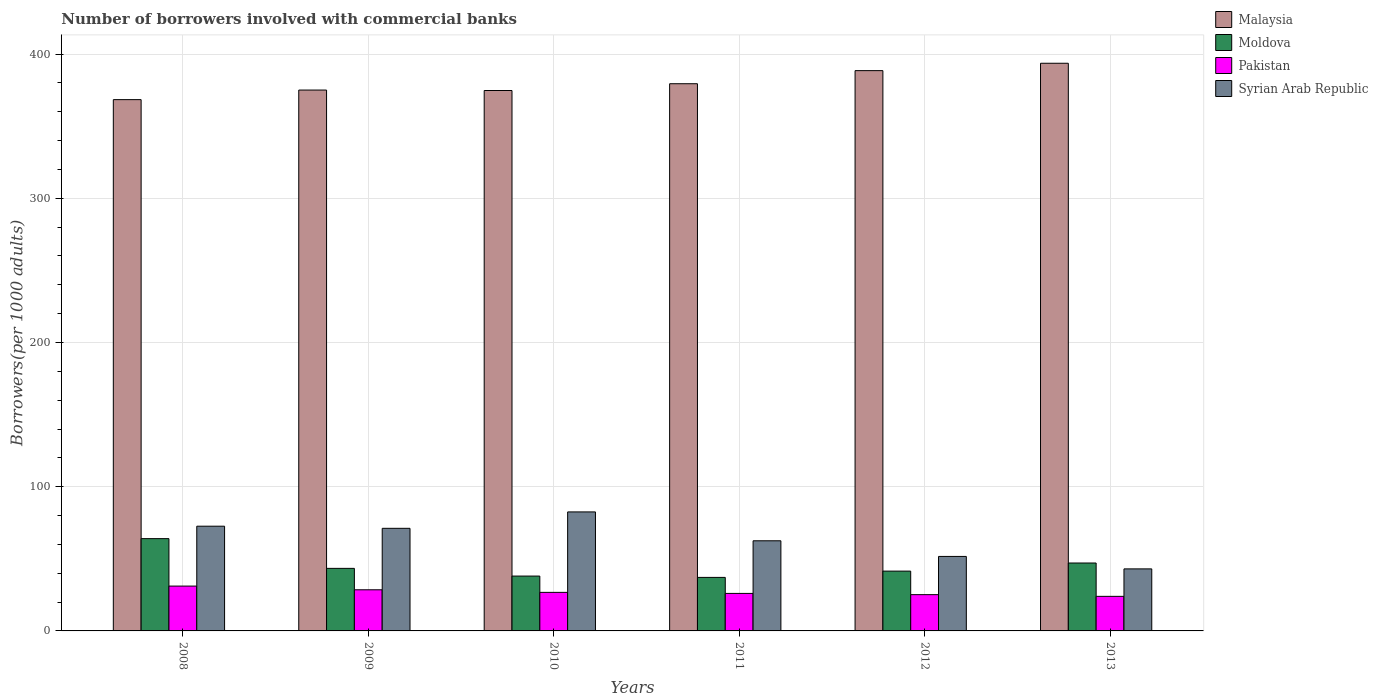How many different coloured bars are there?
Ensure brevity in your answer.  4. How many groups of bars are there?
Offer a terse response. 6. Are the number of bars per tick equal to the number of legend labels?
Provide a short and direct response. Yes. What is the number of borrowers involved with commercial banks in Syrian Arab Republic in 2010?
Ensure brevity in your answer.  82.52. Across all years, what is the maximum number of borrowers involved with commercial banks in Malaysia?
Give a very brief answer. 393.61. Across all years, what is the minimum number of borrowers involved with commercial banks in Moldova?
Provide a short and direct response. 37.11. In which year was the number of borrowers involved with commercial banks in Malaysia minimum?
Provide a succinct answer. 2008. What is the total number of borrowers involved with commercial banks in Malaysia in the graph?
Your answer should be compact. 2279.66. What is the difference between the number of borrowers involved with commercial banks in Pakistan in 2009 and that in 2012?
Your response must be concise. 3.37. What is the difference between the number of borrowers involved with commercial banks in Syrian Arab Republic in 2011 and the number of borrowers involved with commercial banks in Pakistan in 2009?
Keep it short and to the point. 33.98. What is the average number of borrowers involved with commercial banks in Syrian Arab Republic per year?
Ensure brevity in your answer.  63.91. In the year 2013, what is the difference between the number of borrowers involved with commercial banks in Pakistan and number of borrowers involved with commercial banks in Malaysia?
Offer a very short reply. -369.64. In how many years, is the number of borrowers involved with commercial banks in Malaysia greater than 140?
Give a very brief answer. 6. What is the ratio of the number of borrowers involved with commercial banks in Moldova in 2010 to that in 2011?
Offer a very short reply. 1.02. Is the number of borrowers involved with commercial banks in Syrian Arab Republic in 2009 less than that in 2013?
Offer a terse response. No. Is the difference between the number of borrowers involved with commercial banks in Pakistan in 2010 and 2011 greater than the difference between the number of borrowers involved with commercial banks in Malaysia in 2010 and 2011?
Your answer should be compact. Yes. What is the difference between the highest and the second highest number of borrowers involved with commercial banks in Malaysia?
Ensure brevity in your answer.  5.12. What is the difference between the highest and the lowest number of borrowers involved with commercial banks in Moldova?
Offer a terse response. 26.87. Is the sum of the number of borrowers involved with commercial banks in Malaysia in 2010 and 2013 greater than the maximum number of borrowers involved with commercial banks in Moldova across all years?
Your answer should be very brief. Yes. Is it the case that in every year, the sum of the number of borrowers involved with commercial banks in Pakistan and number of borrowers involved with commercial banks in Malaysia is greater than the sum of number of borrowers involved with commercial banks in Moldova and number of borrowers involved with commercial banks in Syrian Arab Republic?
Make the answer very short. No. What does the 4th bar from the left in 2012 represents?
Your answer should be very brief. Syrian Arab Republic. What does the 1st bar from the right in 2008 represents?
Ensure brevity in your answer.  Syrian Arab Republic. How many bars are there?
Your response must be concise. 24. Are the values on the major ticks of Y-axis written in scientific E-notation?
Ensure brevity in your answer.  No. Where does the legend appear in the graph?
Your answer should be very brief. Top right. How many legend labels are there?
Your answer should be compact. 4. What is the title of the graph?
Keep it short and to the point. Number of borrowers involved with commercial banks. Does "High income" appear as one of the legend labels in the graph?
Your answer should be very brief. No. What is the label or title of the X-axis?
Your answer should be compact. Years. What is the label or title of the Y-axis?
Your answer should be compact. Borrowers(per 1000 adults). What is the Borrowers(per 1000 adults) in Malaysia in 2008?
Your response must be concise. 368.39. What is the Borrowers(per 1000 adults) of Moldova in 2008?
Your answer should be compact. 63.99. What is the Borrowers(per 1000 adults) in Pakistan in 2008?
Keep it short and to the point. 31.09. What is the Borrowers(per 1000 adults) of Syrian Arab Republic in 2008?
Your answer should be compact. 72.62. What is the Borrowers(per 1000 adults) of Malaysia in 2009?
Your answer should be compact. 375.03. What is the Borrowers(per 1000 adults) of Moldova in 2009?
Provide a short and direct response. 43.38. What is the Borrowers(per 1000 adults) of Pakistan in 2009?
Offer a terse response. 28.52. What is the Borrowers(per 1000 adults) of Syrian Arab Republic in 2009?
Make the answer very short. 71.15. What is the Borrowers(per 1000 adults) of Malaysia in 2010?
Keep it short and to the point. 374.71. What is the Borrowers(per 1000 adults) of Moldova in 2010?
Your answer should be very brief. 38.03. What is the Borrowers(per 1000 adults) of Pakistan in 2010?
Keep it short and to the point. 26.73. What is the Borrowers(per 1000 adults) in Syrian Arab Republic in 2010?
Provide a short and direct response. 82.52. What is the Borrowers(per 1000 adults) of Malaysia in 2011?
Provide a succinct answer. 379.42. What is the Borrowers(per 1000 adults) in Moldova in 2011?
Your response must be concise. 37.11. What is the Borrowers(per 1000 adults) of Pakistan in 2011?
Your answer should be compact. 26.01. What is the Borrowers(per 1000 adults) of Syrian Arab Republic in 2011?
Provide a succinct answer. 62.5. What is the Borrowers(per 1000 adults) of Malaysia in 2012?
Give a very brief answer. 388.49. What is the Borrowers(per 1000 adults) in Moldova in 2012?
Your answer should be compact. 41.47. What is the Borrowers(per 1000 adults) of Pakistan in 2012?
Provide a succinct answer. 25.15. What is the Borrowers(per 1000 adults) in Syrian Arab Republic in 2012?
Your response must be concise. 51.65. What is the Borrowers(per 1000 adults) in Malaysia in 2013?
Your answer should be compact. 393.61. What is the Borrowers(per 1000 adults) in Moldova in 2013?
Make the answer very short. 47.09. What is the Borrowers(per 1000 adults) in Pakistan in 2013?
Keep it short and to the point. 23.97. What is the Borrowers(per 1000 adults) in Syrian Arab Republic in 2013?
Give a very brief answer. 43.01. Across all years, what is the maximum Borrowers(per 1000 adults) of Malaysia?
Your response must be concise. 393.61. Across all years, what is the maximum Borrowers(per 1000 adults) of Moldova?
Keep it short and to the point. 63.99. Across all years, what is the maximum Borrowers(per 1000 adults) of Pakistan?
Ensure brevity in your answer.  31.09. Across all years, what is the maximum Borrowers(per 1000 adults) in Syrian Arab Republic?
Offer a terse response. 82.52. Across all years, what is the minimum Borrowers(per 1000 adults) in Malaysia?
Offer a very short reply. 368.39. Across all years, what is the minimum Borrowers(per 1000 adults) in Moldova?
Make the answer very short. 37.11. Across all years, what is the minimum Borrowers(per 1000 adults) of Pakistan?
Make the answer very short. 23.97. Across all years, what is the minimum Borrowers(per 1000 adults) of Syrian Arab Republic?
Offer a very short reply. 43.01. What is the total Borrowers(per 1000 adults) in Malaysia in the graph?
Your answer should be very brief. 2279.66. What is the total Borrowers(per 1000 adults) of Moldova in the graph?
Ensure brevity in your answer.  271.07. What is the total Borrowers(per 1000 adults) in Pakistan in the graph?
Keep it short and to the point. 161.46. What is the total Borrowers(per 1000 adults) of Syrian Arab Republic in the graph?
Your response must be concise. 383.44. What is the difference between the Borrowers(per 1000 adults) in Malaysia in 2008 and that in 2009?
Provide a succinct answer. -6.64. What is the difference between the Borrowers(per 1000 adults) of Moldova in 2008 and that in 2009?
Provide a succinct answer. 20.61. What is the difference between the Borrowers(per 1000 adults) of Pakistan in 2008 and that in 2009?
Your response must be concise. 2.57. What is the difference between the Borrowers(per 1000 adults) in Syrian Arab Republic in 2008 and that in 2009?
Make the answer very short. 1.47. What is the difference between the Borrowers(per 1000 adults) of Malaysia in 2008 and that in 2010?
Provide a succinct answer. -6.32. What is the difference between the Borrowers(per 1000 adults) in Moldova in 2008 and that in 2010?
Keep it short and to the point. 25.95. What is the difference between the Borrowers(per 1000 adults) of Pakistan in 2008 and that in 2010?
Provide a short and direct response. 4.36. What is the difference between the Borrowers(per 1000 adults) in Syrian Arab Republic in 2008 and that in 2010?
Make the answer very short. -9.9. What is the difference between the Borrowers(per 1000 adults) of Malaysia in 2008 and that in 2011?
Your answer should be compact. -11.03. What is the difference between the Borrowers(per 1000 adults) of Moldova in 2008 and that in 2011?
Give a very brief answer. 26.87. What is the difference between the Borrowers(per 1000 adults) of Pakistan in 2008 and that in 2011?
Offer a terse response. 5.08. What is the difference between the Borrowers(per 1000 adults) of Syrian Arab Republic in 2008 and that in 2011?
Offer a terse response. 10.12. What is the difference between the Borrowers(per 1000 adults) of Malaysia in 2008 and that in 2012?
Make the answer very short. -20.1. What is the difference between the Borrowers(per 1000 adults) in Moldova in 2008 and that in 2012?
Ensure brevity in your answer.  22.52. What is the difference between the Borrowers(per 1000 adults) in Pakistan in 2008 and that in 2012?
Keep it short and to the point. 5.94. What is the difference between the Borrowers(per 1000 adults) of Syrian Arab Republic in 2008 and that in 2012?
Make the answer very short. 20.97. What is the difference between the Borrowers(per 1000 adults) in Malaysia in 2008 and that in 2013?
Offer a terse response. -25.22. What is the difference between the Borrowers(per 1000 adults) of Moldova in 2008 and that in 2013?
Offer a very short reply. 16.9. What is the difference between the Borrowers(per 1000 adults) of Pakistan in 2008 and that in 2013?
Your response must be concise. 7.13. What is the difference between the Borrowers(per 1000 adults) of Syrian Arab Republic in 2008 and that in 2013?
Offer a very short reply. 29.61. What is the difference between the Borrowers(per 1000 adults) of Malaysia in 2009 and that in 2010?
Ensure brevity in your answer.  0.32. What is the difference between the Borrowers(per 1000 adults) of Moldova in 2009 and that in 2010?
Your answer should be very brief. 5.34. What is the difference between the Borrowers(per 1000 adults) of Pakistan in 2009 and that in 2010?
Offer a very short reply. 1.79. What is the difference between the Borrowers(per 1000 adults) of Syrian Arab Republic in 2009 and that in 2010?
Ensure brevity in your answer.  -11.37. What is the difference between the Borrowers(per 1000 adults) of Malaysia in 2009 and that in 2011?
Offer a terse response. -4.39. What is the difference between the Borrowers(per 1000 adults) of Moldova in 2009 and that in 2011?
Your response must be concise. 6.26. What is the difference between the Borrowers(per 1000 adults) of Pakistan in 2009 and that in 2011?
Provide a short and direct response. 2.51. What is the difference between the Borrowers(per 1000 adults) of Syrian Arab Republic in 2009 and that in 2011?
Make the answer very short. 8.65. What is the difference between the Borrowers(per 1000 adults) of Malaysia in 2009 and that in 2012?
Give a very brief answer. -13.46. What is the difference between the Borrowers(per 1000 adults) of Moldova in 2009 and that in 2012?
Ensure brevity in your answer.  1.91. What is the difference between the Borrowers(per 1000 adults) in Pakistan in 2009 and that in 2012?
Your response must be concise. 3.37. What is the difference between the Borrowers(per 1000 adults) in Syrian Arab Republic in 2009 and that in 2012?
Your response must be concise. 19.5. What is the difference between the Borrowers(per 1000 adults) in Malaysia in 2009 and that in 2013?
Offer a terse response. -18.58. What is the difference between the Borrowers(per 1000 adults) of Moldova in 2009 and that in 2013?
Offer a terse response. -3.71. What is the difference between the Borrowers(per 1000 adults) of Pakistan in 2009 and that in 2013?
Provide a succinct answer. 4.55. What is the difference between the Borrowers(per 1000 adults) in Syrian Arab Republic in 2009 and that in 2013?
Ensure brevity in your answer.  28.13. What is the difference between the Borrowers(per 1000 adults) in Malaysia in 2010 and that in 2011?
Keep it short and to the point. -4.71. What is the difference between the Borrowers(per 1000 adults) in Moldova in 2010 and that in 2011?
Your answer should be compact. 0.92. What is the difference between the Borrowers(per 1000 adults) in Pakistan in 2010 and that in 2011?
Provide a short and direct response. 0.72. What is the difference between the Borrowers(per 1000 adults) of Syrian Arab Republic in 2010 and that in 2011?
Ensure brevity in your answer.  20.02. What is the difference between the Borrowers(per 1000 adults) of Malaysia in 2010 and that in 2012?
Offer a terse response. -13.78. What is the difference between the Borrowers(per 1000 adults) in Moldova in 2010 and that in 2012?
Your response must be concise. -3.43. What is the difference between the Borrowers(per 1000 adults) in Pakistan in 2010 and that in 2012?
Give a very brief answer. 1.58. What is the difference between the Borrowers(per 1000 adults) of Syrian Arab Republic in 2010 and that in 2012?
Provide a succinct answer. 30.87. What is the difference between the Borrowers(per 1000 adults) in Malaysia in 2010 and that in 2013?
Your response must be concise. -18.9. What is the difference between the Borrowers(per 1000 adults) in Moldova in 2010 and that in 2013?
Give a very brief answer. -9.06. What is the difference between the Borrowers(per 1000 adults) of Pakistan in 2010 and that in 2013?
Provide a short and direct response. 2.76. What is the difference between the Borrowers(per 1000 adults) of Syrian Arab Republic in 2010 and that in 2013?
Make the answer very short. 39.51. What is the difference between the Borrowers(per 1000 adults) of Malaysia in 2011 and that in 2012?
Your response must be concise. -9.07. What is the difference between the Borrowers(per 1000 adults) of Moldova in 2011 and that in 2012?
Your answer should be very brief. -4.35. What is the difference between the Borrowers(per 1000 adults) in Pakistan in 2011 and that in 2012?
Provide a succinct answer. 0.86. What is the difference between the Borrowers(per 1000 adults) in Syrian Arab Republic in 2011 and that in 2012?
Offer a terse response. 10.85. What is the difference between the Borrowers(per 1000 adults) in Malaysia in 2011 and that in 2013?
Keep it short and to the point. -14.19. What is the difference between the Borrowers(per 1000 adults) in Moldova in 2011 and that in 2013?
Keep it short and to the point. -9.98. What is the difference between the Borrowers(per 1000 adults) in Pakistan in 2011 and that in 2013?
Provide a succinct answer. 2.04. What is the difference between the Borrowers(per 1000 adults) in Syrian Arab Republic in 2011 and that in 2013?
Offer a very short reply. 19.49. What is the difference between the Borrowers(per 1000 adults) of Malaysia in 2012 and that in 2013?
Give a very brief answer. -5.12. What is the difference between the Borrowers(per 1000 adults) in Moldova in 2012 and that in 2013?
Keep it short and to the point. -5.63. What is the difference between the Borrowers(per 1000 adults) of Pakistan in 2012 and that in 2013?
Offer a very short reply. 1.18. What is the difference between the Borrowers(per 1000 adults) of Syrian Arab Republic in 2012 and that in 2013?
Offer a terse response. 8.63. What is the difference between the Borrowers(per 1000 adults) in Malaysia in 2008 and the Borrowers(per 1000 adults) in Moldova in 2009?
Keep it short and to the point. 325.01. What is the difference between the Borrowers(per 1000 adults) of Malaysia in 2008 and the Borrowers(per 1000 adults) of Pakistan in 2009?
Provide a short and direct response. 339.87. What is the difference between the Borrowers(per 1000 adults) in Malaysia in 2008 and the Borrowers(per 1000 adults) in Syrian Arab Republic in 2009?
Give a very brief answer. 297.25. What is the difference between the Borrowers(per 1000 adults) in Moldova in 2008 and the Borrowers(per 1000 adults) in Pakistan in 2009?
Your answer should be very brief. 35.47. What is the difference between the Borrowers(per 1000 adults) in Moldova in 2008 and the Borrowers(per 1000 adults) in Syrian Arab Republic in 2009?
Provide a short and direct response. -7.16. What is the difference between the Borrowers(per 1000 adults) of Pakistan in 2008 and the Borrowers(per 1000 adults) of Syrian Arab Republic in 2009?
Provide a short and direct response. -40.05. What is the difference between the Borrowers(per 1000 adults) in Malaysia in 2008 and the Borrowers(per 1000 adults) in Moldova in 2010?
Your answer should be very brief. 330.36. What is the difference between the Borrowers(per 1000 adults) of Malaysia in 2008 and the Borrowers(per 1000 adults) of Pakistan in 2010?
Provide a short and direct response. 341.66. What is the difference between the Borrowers(per 1000 adults) in Malaysia in 2008 and the Borrowers(per 1000 adults) in Syrian Arab Republic in 2010?
Offer a very short reply. 285.87. What is the difference between the Borrowers(per 1000 adults) in Moldova in 2008 and the Borrowers(per 1000 adults) in Pakistan in 2010?
Your answer should be compact. 37.26. What is the difference between the Borrowers(per 1000 adults) of Moldova in 2008 and the Borrowers(per 1000 adults) of Syrian Arab Republic in 2010?
Keep it short and to the point. -18.53. What is the difference between the Borrowers(per 1000 adults) in Pakistan in 2008 and the Borrowers(per 1000 adults) in Syrian Arab Republic in 2010?
Provide a succinct answer. -51.43. What is the difference between the Borrowers(per 1000 adults) of Malaysia in 2008 and the Borrowers(per 1000 adults) of Moldova in 2011?
Keep it short and to the point. 331.28. What is the difference between the Borrowers(per 1000 adults) in Malaysia in 2008 and the Borrowers(per 1000 adults) in Pakistan in 2011?
Keep it short and to the point. 342.38. What is the difference between the Borrowers(per 1000 adults) of Malaysia in 2008 and the Borrowers(per 1000 adults) of Syrian Arab Republic in 2011?
Give a very brief answer. 305.89. What is the difference between the Borrowers(per 1000 adults) of Moldova in 2008 and the Borrowers(per 1000 adults) of Pakistan in 2011?
Your answer should be very brief. 37.98. What is the difference between the Borrowers(per 1000 adults) of Moldova in 2008 and the Borrowers(per 1000 adults) of Syrian Arab Republic in 2011?
Your response must be concise. 1.49. What is the difference between the Borrowers(per 1000 adults) in Pakistan in 2008 and the Borrowers(per 1000 adults) in Syrian Arab Republic in 2011?
Ensure brevity in your answer.  -31.41. What is the difference between the Borrowers(per 1000 adults) of Malaysia in 2008 and the Borrowers(per 1000 adults) of Moldova in 2012?
Your answer should be compact. 326.93. What is the difference between the Borrowers(per 1000 adults) of Malaysia in 2008 and the Borrowers(per 1000 adults) of Pakistan in 2012?
Keep it short and to the point. 343.24. What is the difference between the Borrowers(per 1000 adults) in Malaysia in 2008 and the Borrowers(per 1000 adults) in Syrian Arab Republic in 2012?
Offer a very short reply. 316.74. What is the difference between the Borrowers(per 1000 adults) in Moldova in 2008 and the Borrowers(per 1000 adults) in Pakistan in 2012?
Your answer should be very brief. 38.84. What is the difference between the Borrowers(per 1000 adults) of Moldova in 2008 and the Borrowers(per 1000 adults) of Syrian Arab Republic in 2012?
Ensure brevity in your answer.  12.34. What is the difference between the Borrowers(per 1000 adults) of Pakistan in 2008 and the Borrowers(per 1000 adults) of Syrian Arab Republic in 2012?
Provide a short and direct response. -20.55. What is the difference between the Borrowers(per 1000 adults) of Malaysia in 2008 and the Borrowers(per 1000 adults) of Moldova in 2013?
Give a very brief answer. 321.3. What is the difference between the Borrowers(per 1000 adults) of Malaysia in 2008 and the Borrowers(per 1000 adults) of Pakistan in 2013?
Ensure brevity in your answer.  344.43. What is the difference between the Borrowers(per 1000 adults) of Malaysia in 2008 and the Borrowers(per 1000 adults) of Syrian Arab Republic in 2013?
Ensure brevity in your answer.  325.38. What is the difference between the Borrowers(per 1000 adults) of Moldova in 2008 and the Borrowers(per 1000 adults) of Pakistan in 2013?
Provide a succinct answer. 40.02. What is the difference between the Borrowers(per 1000 adults) of Moldova in 2008 and the Borrowers(per 1000 adults) of Syrian Arab Republic in 2013?
Offer a terse response. 20.98. What is the difference between the Borrowers(per 1000 adults) of Pakistan in 2008 and the Borrowers(per 1000 adults) of Syrian Arab Republic in 2013?
Offer a terse response. -11.92. What is the difference between the Borrowers(per 1000 adults) of Malaysia in 2009 and the Borrowers(per 1000 adults) of Moldova in 2010?
Provide a succinct answer. 336.99. What is the difference between the Borrowers(per 1000 adults) in Malaysia in 2009 and the Borrowers(per 1000 adults) in Pakistan in 2010?
Offer a terse response. 348.3. What is the difference between the Borrowers(per 1000 adults) of Malaysia in 2009 and the Borrowers(per 1000 adults) of Syrian Arab Republic in 2010?
Offer a terse response. 292.51. What is the difference between the Borrowers(per 1000 adults) of Moldova in 2009 and the Borrowers(per 1000 adults) of Pakistan in 2010?
Offer a very short reply. 16.65. What is the difference between the Borrowers(per 1000 adults) in Moldova in 2009 and the Borrowers(per 1000 adults) in Syrian Arab Republic in 2010?
Your answer should be very brief. -39.14. What is the difference between the Borrowers(per 1000 adults) of Pakistan in 2009 and the Borrowers(per 1000 adults) of Syrian Arab Republic in 2010?
Give a very brief answer. -54. What is the difference between the Borrowers(per 1000 adults) in Malaysia in 2009 and the Borrowers(per 1000 adults) in Moldova in 2011?
Give a very brief answer. 337.91. What is the difference between the Borrowers(per 1000 adults) in Malaysia in 2009 and the Borrowers(per 1000 adults) in Pakistan in 2011?
Provide a succinct answer. 349.02. What is the difference between the Borrowers(per 1000 adults) in Malaysia in 2009 and the Borrowers(per 1000 adults) in Syrian Arab Republic in 2011?
Provide a short and direct response. 312.53. What is the difference between the Borrowers(per 1000 adults) of Moldova in 2009 and the Borrowers(per 1000 adults) of Pakistan in 2011?
Ensure brevity in your answer.  17.37. What is the difference between the Borrowers(per 1000 adults) in Moldova in 2009 and the Borrowers(per 1000 adults) in Syrian Arab Republic in 2011?
Ensure brevity in your answer.  -19.12. What is the difference between the Borrowers(per 1000 adults) of Pakistan in 2009 and the Borrowers(per 1000 adults) of Syrian Arab Republic in 2011?
Keep it short and to the point. -33.98. What is the difference between the Borrowers(per 1000 adults) of Malaysia in 2009 and the Borrowers(per 1000 adults) of Moldova in 2012?
Provide a short and direct response. 333.56. What is the difference between the Borrowers(per 1000 adults) of Malaysia in 2009 and the Borrowers(per 1000 adults) of Pakistan in 2012?
Offer a very short reply. 349.88. What is the difference between the Borrowers(per 1000 adults) in Malaysia in 2009 and the Borrowers(per 1000 adults) in Syrian Arab Republic in 2012?
Your response must be concise. 323.38. What is the difference between the Borrowers(per 1000 adults) of Moldova in 2009 and the Borrowers(per 1000 adults) of Pakistan in 2012?
Your answer should be compact. 18.23. What is the difference between the Borrowers(per 1000 adults) of Moldova in 2009 and the Borrowers(per 1000 adults) of Syrian Arab Republic in 2012?
Offer a very short reply. -8.27. What is the difference between the Borrowers(per 1000 adults) of Pakistan in 2009 and the Borrowers(per 1000 adults) of Syrian Arab Republic in 2012?
Provide a short and direct response. -23.13. What is the difference between the Borrowers(per 1000 adults) of Malaysia in 2009 and the Borrowers(per 1000 adults) of Moldova in 2013?
Your answer should be compact. 327.94. What is the difference between the Borrowers(per 1000 adults) in Malaysia in 2009 and the Borrowers(per 1000 adults) in Pakistan in 2013?
Make the answer very short. 351.06. What is the difference between the Borrowers(per 1000 adults) of Malaysia in 2009 and the Borrowers(per 1000 adults) of Syrian Arab Republic in 2013?
Your answer should be very brief. 332.02. What is the difference between the Borrowers(per 1000 adults) in Moldova in 2009 and the Borrowers(per 1000 adults) in Pakistan in 2013?
Give a very brief answer. 19.41. What is the difference between the Borrowers(per 1000 adults) in Moldova in 2009 and the Borrowers(per 1000 adults) in Syrian Arab Republic in 2013?
Your answer should be very brief. 0.37. What is the difference between the Borrowers(per 1000 adults) in Pakistan in 2009 and the Borrowers(per 1000 adults) in Syrian Arab Republic in 2013?
Give a very brief answer. -14.49. What is the difference between the Borrowers(per 1000 adults) in Malaysia in 2010 and the Borrowers(per 1000 adults) in Moldova in 2011?
Your answer should be compact. 337.6. What is the difference between the Borrowers(per 1000 adults) of Malaysia in 2010 and the Borrowers(per 1000 adults) of Pakistan in 2011?
Your answer should be compact. 348.7. What is the difference between the Borrowers(per 1000 adults) of Malaysia in 2010 and the Borrowers(per 1000 adults) of Syrian Arab Republic in 2011?
Your answer should be very brief. 312.22. What is the difference between the Borrowers(per 1000 adults) of Moldova in 2010 and the Borrowers(per 1000 adults) of Pakistan in 2011?
Provide a succinct answer. 12.03. What is the difference between the Borrowers(per 1000 adults) of Moldova in 2010 and the Borrowers(per 1000 adults) of Syrian Arab Republic in 2011?
Your response must be concise. -24.46. What is the difference between the Borrowers(per 1000 adults) in Pakistan in 2010 and the Borrowers(per 1000 adults) in Syrian Arab Republic in 2011?
Offer a very short reply. -35.77. What is the difference between the Borrowers(per 1000 adults) of Malaysia in 2010 and the Borrowers(per 1000 adults) of Moldova in 2012?
Ensure brevity in your answer.  333.25. What is the difference between the Borrowers(per 1000 adults) in Malaysia in 2010 and the Borrowers(per 1000 adults) in Pakistan in 2012?
Make the answer very short. 349.57. What is the difference between the Borrowers(per 1000 adults) of Malaysia in 2010 and the Borrowers(per 1000 adults) of Syrian Arab Republic in 2012?
Ensure brevity in your answer.  323.07. What is the difference between the Borrowers(per 1000 adults) in Moldova in 2010 and the Borrowers(per 1000 adults) in Pakistan in 2012?
Offer a very short reply. 12.89. What is the difference between the Borrowers(per 1000 adults) in Moldova in 2010 and the Borrowers(per 1000 adults) in Syrian Arab Republic in 2012?
Give a very brief answer. -13.61. What is the difference between the Borrowers(per 1000 adults) of Pakistan in 2010 and the Borrowers(per 1000 adults) of Syrian Arab Republic in 2012?
Your response must be concise. -24.92. What is the difference between the Borrowers(per 1000 adults) in Malaysia in 2010 and the Borrowers(per 1000 adults) in Moldova in 2013?
Offer a terse response. 327.62. What is the difference between the Borrowers(per 1000 adults) of Malaysia in 2010 and the Borrowers(per 1000 adults) of Pakistan in 2013?
Your answer should be compact. 350.75. What is the difference between the Borrowers(per 1000 adults) in Malaysia in 2010 and the Borrowers(per 1000 adults) in Syrian Arab Republic in 2013?
Give a very brief answer. 331.7. What is the difference between the Borrowers(per 1000 adults) of Moldova in 2010 and the Borrowers(per 1000 adults) of Pakistan in 2013?
Your answer should be compact. 14.07. What is the difference between the Borrowers(per 1000 adults) of Moldova in 2010 and the Borrowers(per 1000 adults) of Syrian Arab Republic in 2013?
Ensure brevity in your answer.  -4.98. What is the difference between the Borrowers(per 1000 adults) in Pakistan in 2010 and the Borrowers(per 1000 adults) in Syrian Arab Republic in 2013?
Ensure brevity in your answer.  -16.28. What is the difference between the Borrowers(per 1000 adults) of Malaysia in 2011 and the Borrowers(per 1000 adults) of Moldova in 2012?
Ensure brevity in your answer.  337.95. What is the difference between the Borrowers(per 1000 adults) of Malaysia in 2011 and the Borrowers(per 1000 adults) of Pakistan in 2012?
Your answer should be very brief. 354.27. What is the difference between the Borrowers(per 1000 adults) in Malaysia in 2011 and the Borrowers(per 1000 adults) in Syrian Arab Republic in 2012?
Your answer should be very brief. 327.77. What is the difference between the Borrowers(per 1000 adults) in Moldova in 2011 and the Borrowers(per 1000 adults) in Pakistan in 2012?
Make the answer very short. 11.97. What is the difference between the Borrowers(per 1000 adults) in Moldova in 2011 and the Borrowers(per 1000 adults) in Syrian Arab Republic in 2012?
Keep it short and to the point. -14.53. What is the difference between the Borrowers(per 1000 adults) in Pakistan in 2011 and the Borrowers(per 1000 adults) in Syrian Arab Republic in 2012?
Your answer should be very brief. -25.64. What is the difference between the Borrowers(per 1000 adults) in Malaysia in 2011 and the Borrowers(per 1000 adults) in Moldova in 2013?
Your response must be concise. 332.33. What is the difference between the Borrowers(per 1000 adults) in Malaysia in 2011 and the Borrowers(per 1000 adults) in Pakistan in 2013?
Ensure brevity in your answer.  355.45. What is the difference between the Borrowers(per 1000 adults) of Malaysia in 2011 and the Borrowers(per 1000 adults) of Syrian Arab Republic in 2013?
Your answer should be very brief. 336.41. What is the difference between the Borrowers(per 1000 adults) of Moldova in 2011 and the Borrowers(per 1000 adults) of Pakistan in 2013?
Keep it short and to the point. 13.15. What is the difference between the Borrowers(per 1000 adults) of Moldova in 2011 and the Borrowers(per 1000 adults) of Syrian Arab Republic in 2013?
Provide a short and direct response. -5.9. What is the difference between the Borrowers(per 1000 adults) of Pakistan in 2011 and the Borrowers(per 1000 adults) of Syrian Arab Republic in 2013?
Give a very brief answer. -17. What is the difference between the Borrowers(per 1000 adults) of Malaysia in 2012 and the Borrowers(per 1000 adults) of Moldova in 2013?
Provide a short and direct response. 341.4. What is the difference between the Borrowers(per 1000 adults) of Malaysia in 2012 and the Borrowers(per 1000 adults) of Pakistan in 2013?
Offer a very short reply. 364.53. What is the difference between the Borrowers(per 1000 adults) in Malaysia in 2012 and the Borrowers(per 1000 adults) in Syrian Arab Republic in 2013?
Give a very brief answer. 345.48. What is the difference between the Borrowers(per 1000 adults) of Moldova in 2012 and the Borrowers(per 1000 adults) of Pakistan in 2013?
Give a very brief answer. 17.5. What is the difference between the Borrowers(per 1000 adults) of Moldova in 2012 and the Borrowers(per 1000 adults) of Syrian Arab Republic in 2013?
Your response must be concise. -1.55. What is the difference between the Borrowers(per 1000 adults) of Pakistan in 2012 and the Borrowers(per 1000 adults) of Syrian Arab Republic in 2013?
Keep it short and to the point. -17.86. What is the average Borrowers(per 1000 adults) of Malaysia per year?
Provide a succinct answer. 379.94. What is the average Borrowers(per 1000 adults) in Moldova per year?
Your answer should be very brief. 45.18. What is the average Borrowers(per 1000 adults) in Pakistan per year?
Your answer should be compact. 26.91. What is the average Borrowers(per 1000 adults) of Syrian Arab Republic per year?
Ensure brevity in your answer.  63.91. In the year 2008, what is the difference between the Borrowers(per 1000 adults) of Malaysia and Borrowers(per 1000 adults) of Moldova?
Make the answer very short. 304.4. In the year 2008, what is the difference between the Borrowers(per 1000 adults) in Malaysia and Borrowers(per 1000 adults) in Pakistan?
Make the answer very short. 337.3. In the year 2008, what is the difference between the Borrowers(per 1000 adults) in Malaysia and Borrowers(per 1000 adults) in Syrian Arab Republic?
Your answer should be compact. 295.77. In the year 2008, what is the difference between the Borrowers(per 1000 adults) in Moldova and Borrowers(per 1000 adults) in Pakistan?
Provide a succinct answer. 32.9. In the year 2008, what is the difference between the Borrowers(per 1000 adults) in Moldova and Borrowers(per 1000 adults) in Syrian Arab Republic?
Your response must be concise. -8.63. In the year 2008, what is the difference between the Borrowers(per 1000 adults) in Pakistan and Borrowers(per 1000 adults) in Syrian Arab Republic?
Your answer should be compact. -41.53. In the year 2009, what is the difference between the Borrowers(per 1000 adults) in Malaysia and Borrowers(per 1000 adults) in Moldova?
Make the answer very short. 331.65. In the year 2009, what is the difference between the Borrowers(per 1000 adults) in Malaysia and Borrowers(per 1000 adults) in Pakistan?
Provide a succinct answer. 346.51. In the year 2009, what is the difference between the Borrowers(per 1000 adults) in Malaysia and Borrowers(per 1000 adults) in Syrian Arab Republic?
Offer a terse response. 303.88. In the year 2009, what is the difference between the Borrowers(per 1000 adults) in Moldova and Borrowers(per 1000 adults) in Pakistan?
Your response must be concise. 14.86. In the year 2009, what is the difference between the Borrowers(per 1000 adults) in Moldova and Borrowers(per 1000 adults) in Syrian Arab Republic?
Offer a very short reply. -27.77. In the year 2009, what is the difference between the Borrowers(per 1000 adults) of Pakistan and Borrowers(per 1000 adults) of Syrian Arab Republic?
Offer a very short reply. -42.62. In the year 2010, what is the difference between the Borrowers(per 1000 adults) of Malaysia and Borrowers(per 1000 adults) of Moldova?
Offer a very short reply. 336.68. In the year 2010, what is the difference between the Borrowers(per 1000 adults) in Malaysia and Borrowers(per 1000 adults) in Pakistan?
Make the answer very short. 347.98. In the year 2010, what is the difference between the Borrowers(per 1000 adults) in Malaysia and Borrowers(per 1000 adults) in Syrian Arab Republic?
Ensure brevity in your answer.  292.19. In the year 2010, what is the difference between the Borrowers(per 1000 adults) in Moldova and Borrowers(per 1000 adults) in Pakistan?
Keep it short and to the point. 11.31. In the year 2010, what is the difference between the Borrowers(per 1000 adults) of Moldova and Borrowers(per 1000 adults) of Syrian Arab Republic?
Offer a very short reply. -44.48. In the year 2010, what is the difference between the Borrowers(per 1000 adults) of Pakistan and Borrowers(per 1000 adults) of Syrian Arab Republic?
Give a very brief answer. -55.79. In the year 2011, what is the difference between the Borrowers(per 1000 adults) of Malaysia and Borrowers(per 1000 adults) of Moldova?
Give a very brief answer. 342.3. In the year 2011, what is the difference between the Borrowers(per 1000 adults) in Malaysia and Borrowers(per 1000 adults) in Pakistan?
Keep it short and to the point. 353.41. In the year 2011, what is the difference between the Borrowers(per 1000 adults) of Malaysia and Borrowers(per 1000 adults) of Syrian Arab Republic?
Make the answer very short. 316.92. In the year 2011, what is the difference between the Borrowers(per 1000 adults) of Moldova and Borrowers(per 1000 adults) of Pakistan?
Give a very brief answer. 11.11. In the year 2011, what is the difference between the Borrowers(per 1000 adults) in Moldova and Borrowers(per 1000 adults) in Syrian Arab Republic?
Ensure brevity in your answer.  -25.38. In the year 2011, what is the difference between the Borrowers(per 1000 adults) of Pakistan and Borrowers(per 1000 adults) of Syrian Arab Republic?
Give a very brief answer. -36.49. In the year 2012, what is the difference between the Borrowers(per 1000 adults) of Malaysia and Borrowers(per 1000 adults) of Moldova?
Provide a succinct answer. 347.03. In the year 2012, what is the difference between the Borrowers(per 1000 adults) of Malaysia and Borrowers(per 1000 adults) of Pakistan?
Provide a short and direct response. 363.34. In the year 2012, what is the difference between the Borrowers(per 1000 adults) in Malaysia and Borrowers(per 1000 adults) in Syrian Arab Republic?
Make the answer very short. 336.85. In the year 2012, what is the difference between the Borrowers(per 1000 adults) in Moldova and Borrowers(per 1000 adults) in Pakistan?
Give a very brief answer. 16.32. In the year 2012, what is the difference between the Borrowers(per 1000 adults) in Moldova and Borrowers(per 1000 adults) in Syrian Arab Republic?
Offer a very short reply. -10.18. In the year 2012, what is the difference between the Borrowers(per 1000 adults) of Pakistan and Borrowers(per 1000 adults) of Syrian Arab Republic?
Keep it short and to the point. -26.5. In the year 2013, what is the difference between the Borrowers(per 1000 adults) in Malaysia and Borrowers(per 1000 adults) in Moldova?
Ensure brevity in your answer.  346.52. In the year 2013, what is the difference between the Borrowers(per 1000 adults) in Malaysia and Borrowers(per 1000 adults) in Pakistan?
Make the answer very short. 369.64. In the year 2013, what is the difference between the Borrowers(per 1000 adults) of Malaysia and Borrowers(per 1000 adults) of Syrian Arab Republic?
Provide a succinct answer. 350.6. In the year 2013, what is the difference between the Borrowers(per 1000 adults) in Moldova and Borrowers(per 1000 adults) in Pakistan?
Provide a short and direct response. 23.13. In the year 2013, what is the difference between the Borrowers(per 1000 adults) in Moldova and Borrowers(per 1000 adults) in Syrian Arab Republic?
Your answer should be compact. 4.08. In the year 2013, what is the difference between the Borrowers(per 1000 adults) of Pakistan and Borrowers(per 1000 adults) of Syrian Arab Republic?
Offer a very short reply. -19.05. What is the ratio of the Borrowers(per 1000 adults) of Malaysia in 2008 to that in 2009?
Your response must be concise. 0.98. What is the ratio of the Borrowers(per 1000 adults) of Moldova in 2008 to that in 2009?
Offer a terse response. 1.48. What is the ratio of the Borrowers(per 1000 adults) of Pakistan in 2008 to that in 2009?
Your response must be concise. 1.09. What is the ratio of the Borrowers(per 1000 adults) in Syrian Arab Republic in 2008 to that in 2009?
Your response must be concise. 1.02. What is the ratio of the Borrowers(per 1000 adults) of Malaysia in 2008 to that in 2010?
Your response must be concise. 0.98. What is the ratio of the Borrowers(per 1000 adults) of Moldova in 2008 to that in 2010?
Give a very brief answer. 1.68. What is the ratio of the Borrowers(per 1000 adults) in Pakistan in 2008 to that in 2010?
Keep it short and to the point. 1.16. What is the ratio of the Borrowers(per 1000 adults) of Syrian Arab Republic in 2008 to that in 2010?
Your response must be concise. 0.88. What is the ratio of the Borrowers(per 1000 adults) of Malaysia in 2008 to that in 2011?
Keep it short and to the point. 0.97. What is the ratio of the Borrowers(per 1000 adults) of Moldova in 2008 to that in 2011?
Offer a very short reply. 1.72. What is the ratio of the Borrowers(per 1000 adults) in Pakistan in 2008 to that in 2011?
Your answer should be compact. 1.2. What is the ratio of the Borrowers(per 1000 adults) in Syrian Arab Republic in 2008 to that in 2011?
Your response must be concise. 1.16. What is the ratio of the Borrowers(per 1000 adults) in Malaysia in 2008 to that in 2012?
Give a very brief answer. 0.95. What is the ratio of the Borrowers(per 1000 adults) in Moldova in 2008 to that in 2012?
Your response must be concise. 1.54. What is the ratio of the Borrowers(per 1000 adults) of Pakistan in 2008 to that in 2012?
Your response must be concise. 1.24. What is the ratio of the Borrowers(per 1000 adults) of Syrian Arab Republic in 2008 to that in 2012?
Your answer should be compact. 1.41. What is the ratio of the Borrowers(per 1000 adults) of Malaysia in 2008 to that in 2013?
Provide a short and direct response. 0.94. What is the ratio of the Borrowers(per 1000 adults) of Moldova in 2008 to that in 2013?
Your answer should be compact. 1.36. What is the ratio of the Borrowers(per 1000 adults) in Pakistan in 2008 to that in 2013?
Offer a terse response. 1.3. What is the ratio of the Borrowers(per 1000 adults) of Syrian Arab Republic in 2008 to that in 2013?
Offer a very short reply. 1.69. What is the ratio of the Borrowers(per 1000 adults) in Moldova in 2009 to that in 2010?
Keep it short and to the point. 1.14. What is the ratio of the Borrowers(per 1000 adults) in Pakistan in 2009 to that in 2010?
Give a very brief answer. 1.07. What is the ratio of the Borrowers(per 1000 adults) in Syrian Arab Republic in 2009 to that in 2010?
Your answer should be compact. 0.86. What is the ratio of the Borrowers(per 1000 adults) in Malaysia in 2009 to that in 2011?
Give a very brief answer. 0.99. What is the ratio of the Borrowers(per 1000 adults) in Moldova in 2009 to that in 2011?
Give a very brief answer. 1.17. What is the ratio of the Borrowers(per 1000 adults) in Pakistan in 2009 to that in 2011?
Your response must be concise. 1.1. What is the ratio of the Borrowers(per 1000 adults) in Syrian Arab Republic in 2009 to that in 2011?
Offer a terse response. 1.14. What is the ratio of the Borrowers(per 1000 adults) of Malaysia in 2009 to that in 2012?
Make the answer very short. 0.97. What is the ratio of the Borrowers(per 1000 adults) in Moldova in 2009 to that in 2012?
Give a very brief answer. 1.05. What is the ratio of the Borrowers(per 1000 adults) of Pakistan in 2009 to that in 2012?
Keep it short and to the point. 1.13. What is the ratio of the Borrowers(per 1000 adults) of Syrian Arab Republic in 2009 to that in 2012?
Your answer should be very brief. 1.38. What is the ratio of the Borrowers(per 1000 adults) of Malaysia in 2009 to that in 2013?
Make the answer very short. 0.95. What is the ratio of the Borrowers(per 1000 adults) of Moldova in 2009 to that in 2013?
Provide a short and direct response. 0.92. What is the ratio of the Borrowers(per 1000 adults) in Pakistan in 2009 to that in 2013?
Provide a short and direct response. 1.19. What is the ratio of the Borrowers(per 1000 adults) in Syrian Arab Republic in 2009 to that in 2013?
Keep it short and to the point. 1.65. What is the ratio of the Borrowers(per 1000 adults) of Malaysia in 2010 to that in 2011?
Offer a very short reply. 0.99. What is the ratio of the Borrowers(per 1000 adults) of Moldova in 2010 to that in 2011?
Your answer should be compact. 1.02. What is the ratio of the Borrowers(per 1000 adults) of Pakistan in 2010 to that in 2011?
Make the answer very short. 1.03. What is the ratio of the Borrowers(per 1000 adults) of Syrian Arab Republic in 2010 to that in 2011?
Ensure brevity in your answer.  1.32. What is the ratio of the Borrowers(per 1000 adults) in Malaysia in 2010 to that in 2012?
Provide a succinct answer. 0.96. What is the ratio of the Borrowers(per 1000 adults) in Moldova in 2010 to that in 2012?
Ensure brevity in your answer.  0.92. What is the ratio of the Borrowers(per 1000 adults) of Pakistan in 2010 to that in 2012?
Give a very brief answer. 1.06. What is the ratio of the Borrowers(per 1000 adults) in Syrian Arab Republic in 2010 to that in 2012?
Provide a succinct answer. 1.6. What is the ratio of the Borrowers(per 1000 adults) of Moldova in 2010 to that in 2013?
Your answer should be very brief. 0.81. What is the ratio of the Borrowers(per 1000 adults) of Pakistan in 2010 to that in 2013?
Your answer should be compact. 1.12. What is the ratio of the Borrowers(per 1000 adults) in Syrian Arab Republic in 2010 to that in 2013?
Provide a short and direct response. 1.92. What is the ratio of the Borrowers(per 1000 adults) in Malaysia in 2011 to that in 2012?
Give a very brief answer. 0.98. What is the ratio of the Borrowers(per 1000 adults) in Moldova in 2011 to that in 2012?
Make the answer very short. 0.9. What is the ratio of the Borrowers(per 1000 adults) in Pakistan in 2011 to that in 2012?
Provide a short and direct response. 1.03. What is the ratio of the Borrowers(per 1000 adults) of Syrian Arab Republic in 2011 to that in 2012?
Make the answer very short. 1.21. What is the ratio of the Borrowers(per 1000 adults) of Malaysia in 2011 to that in 2013?
Ensure brevity in your answer.  0.96. What is the ratio of the Borrowers(per 1000 adults) of Moldova in 2011 to that in 2013?
Your answer should be compact. 0.79. What is the ratio of the Borrowers(per 1000 adults) of Pakistan in 2011 to that in 2013?
Your response must be concise. 1.09. What is the ratio of the Borrowers(per 1000 adults) of Syrian Arab Republic in 2011 to that in 2013?
Offer a terse response. 1.45. What is the ratio of the Borrowers(per 1000 adults) of Moldova in 2012 to that in 2013?
Offer a terse response. 0.88. What is the ratio of the Borrowers(per 1000 adults) of Pakistan in 2012 to that in 2013?
Offer a terse response. 1.05. What is the ratio of the Borrowers(per 1000 adults) in Syrian Arab Republic in 2012 to that in 2013?
Make the answer very short. 1.2. What is the difference between the highest and the second highest Borrowers(per 1000 adults) in Malaysia?
Your answer should be very brief. 5.12. What is the difference between the highest and the second highest Borrowers(per 1000 adults) in Moldova?
Keep it short and to the point. 16.9. What is the difference between the highest and the second highest Borrowers(per 1000 adults) in Pakistan?
Provide a succinct answer. 2.57. What is the difference between the highest and the second highest Borrowers(per 1000 adults) in Syrian Arab Republic?
Provide a succinct answer. 9.9. What is the difference between the highest and the lowest Borrowers(per 1000 adults) of Malaysia?
Provide a succinct answer. 25.22. What is the difference between the highest and the lowest Borrowers(per 1000 adults) in Moldova?
Offer a terse response. 26.87. What is the difference between the highest and the lowest Borrowers(per 1000 adults) in Pakistan?
Offer a terse response. 7.13. What is the difference between the highest and the lowest Borrowers(per 1000 adults) in Syrian Arab Republic?
Your response must be concise. 39.51. 